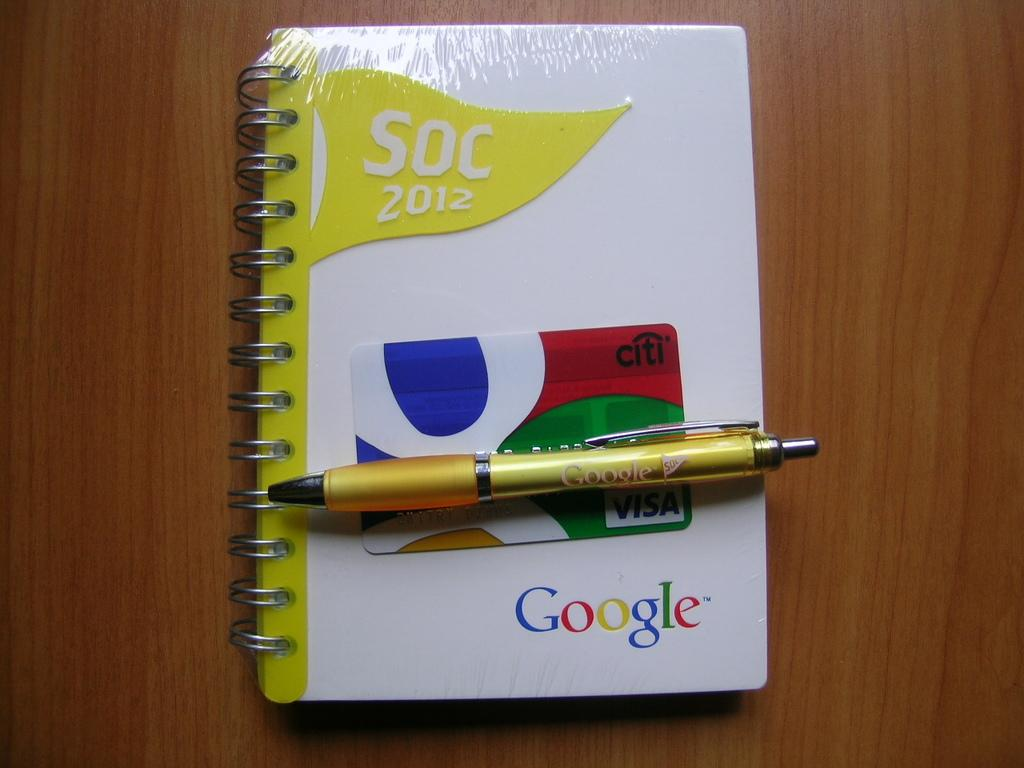What stationery item can be seen in the image? There is a pen in the image. What other object is present in the image? There is a card in the image. What is the third object visible in the image? There is a book in the image. On what type of surface is the book placed? The book is on a wooden object. How many firemen are present in the image? There are no firemen present in the image. What type of chickens can be seen interacting with the pen in the image? There are no chickens present in the image, and therefore no such interaction can be observed. 